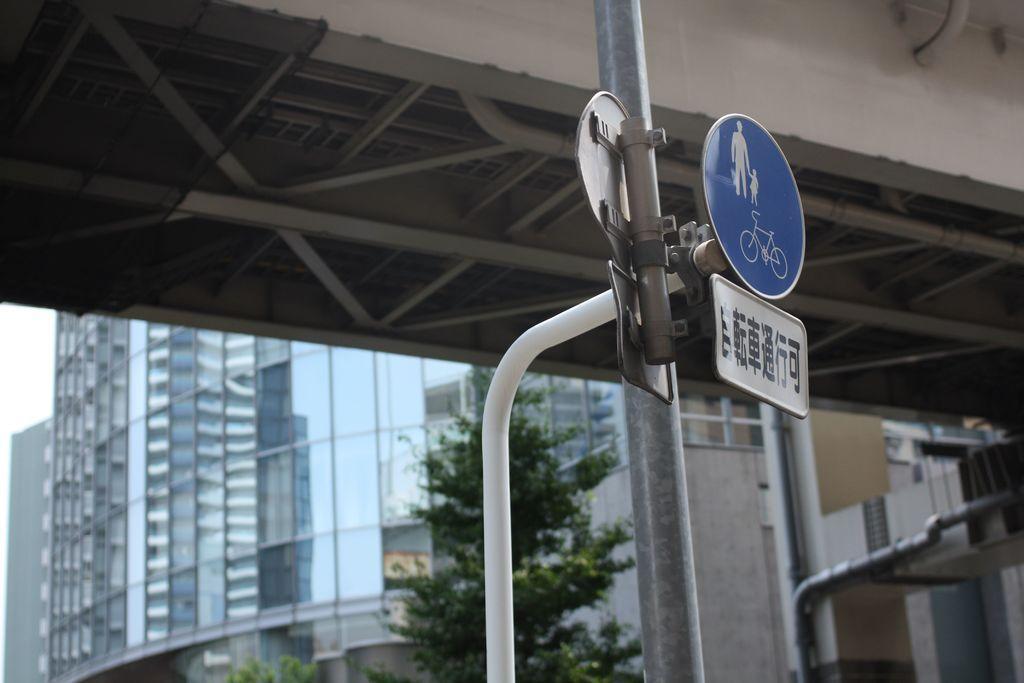In one or two sentences, can you explain what this image depicts? In this image we can see a pole with sign board attached to it. In the background there are buildings and trees. 